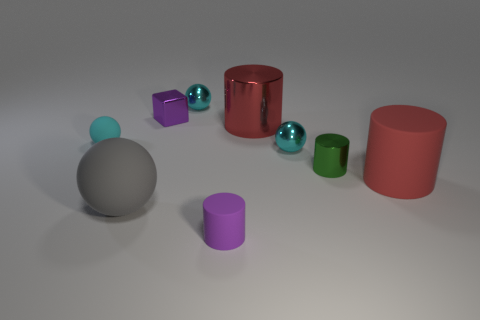Are there any tiny purple blocks that have the same material as the tiny green thing?
Keep it short and to the point. Yes. What is the shape of the small purple shiny object?
Ensure brevity in your answer.  Cube. Is the size of the purple metallic thing the same as the gray ball?
Offer a terse response. No. What number of other things are the same shape as the tiny purple rubber object?
Give a very brief answer. 3. What is the shape of the small matte thing in front of the small cyan matte object?
Offer a very short reply. Cylinder. Is the shape of the big thing that is behind the green thing the same as the large rubber thing to the right of the tiny purple rubber cylinder?
Your answer should be compact. Yes. Is the number of small purple cylinders behind the purple cylinder the same as the number of big rubber things?
Your answer should be very brief. No. What is the material of the tiny purple thing that is the same shape as the big metallic object?
Make the answer very short. Rubber. What is the shape of the big thing left of the small matte thing in front of the big red rubber cylinder?
Your response must be concise. Sphere. Is the material of the small cyan sphere to the right of the purple matte object the same as the large gray thing?
Give a very brief answer. No. 